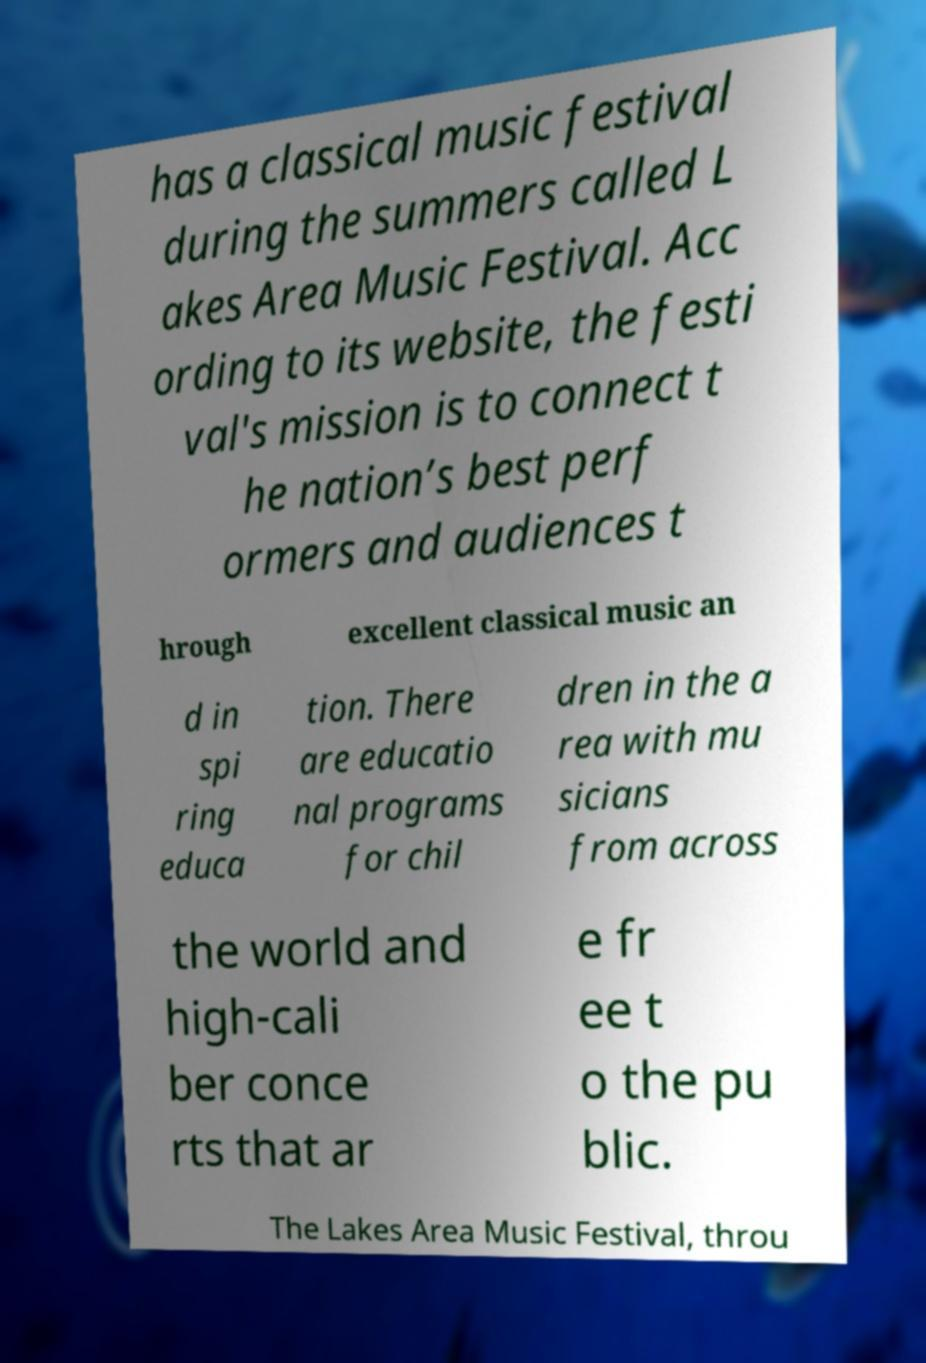Can you read and provide the text displayed in the image?This photo seems to have some interesting text. Can you extract and type it out for me? has a classical music festival during the summers called L akes Area Music Festival. Acc ording to its website, the festi val's mission is to connect t he nation’s best perf ormers and audiences t hrough excellent classical music an d in spi ring educa tion. There are educatio nal programs for chil dren in the a rea with mu sicians from across the world and high-cali ber conce rts that ar e fr ee t o the pu blic. The Lakes Area Music Festival, throu 